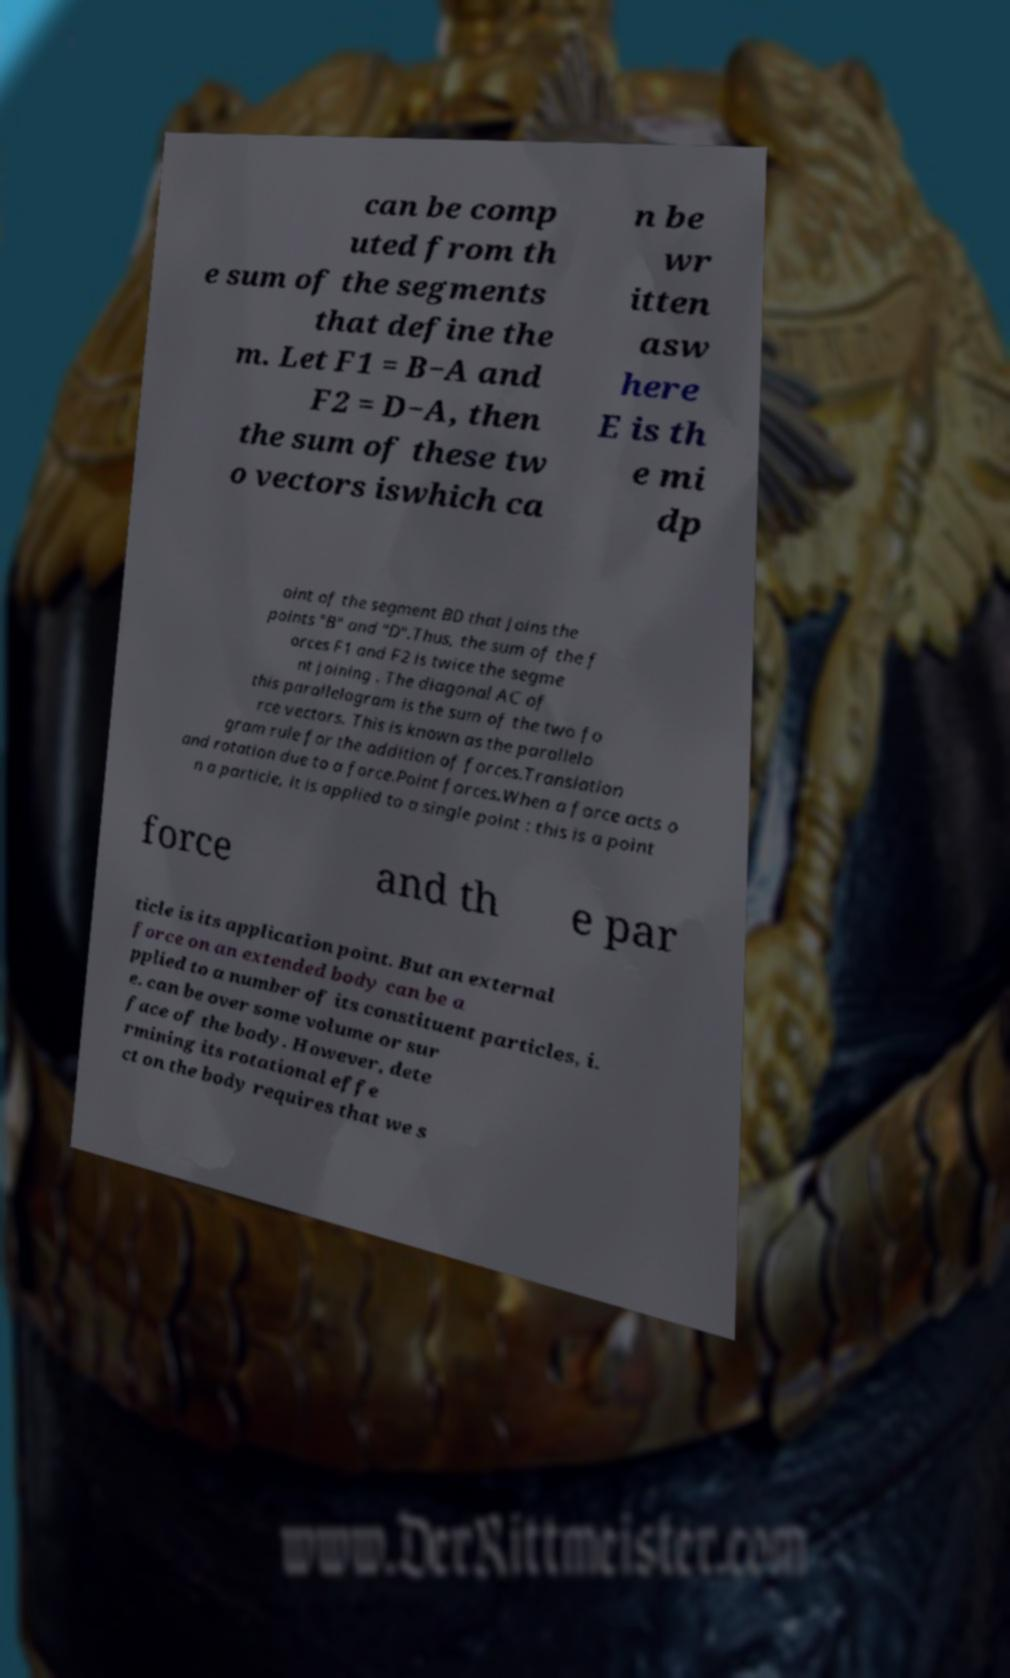For documentation purposes, I need the text within this image transcribed. Could you provide that? can be comp uted from th e sum of the segments that define the m. Let F1 = B−A and F2 = D−A, then the sum of these tw o vectors iswhich ca n be wr itten asw here E is th e mi dp oint of the segment BD that joins the points "B" and "D".Thus, the sum of the f orces F1 and F2 is twice the segme nt joining . The diagonal AC of this parallelogram is the sum of the two fo rce vectors. This is known as the parallelo gram rule for the addition of forces.Translation and rotation due to a force.Point forces.When a force acts o n a particle, it is applied to a single point : this is a point force and th e par ticle is its application point. But an external force on an extended body can be a pplied to a number of its constituent particles, i. e. can be over some volume or sur face of the body. However, dete rmining its rotational effe ct on the body requires that we s 